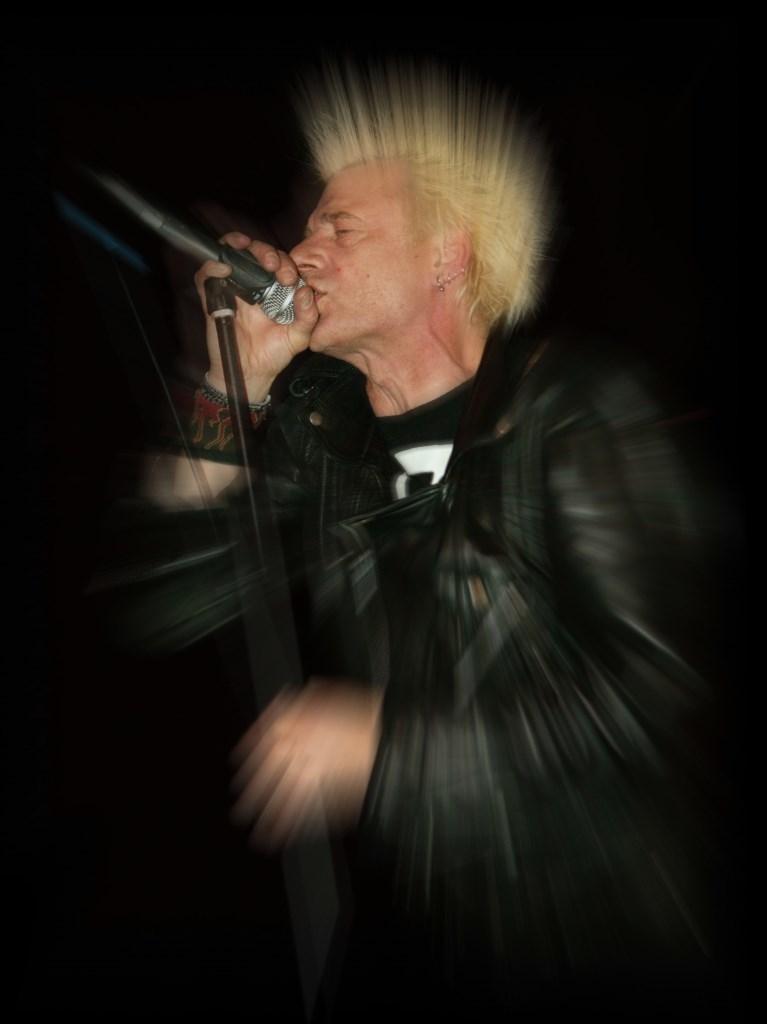In one or two sentences, can you explain what this image depicts? As we can see in the image there is a man wearing black color jacket and holding mic. The image is little blurred. 